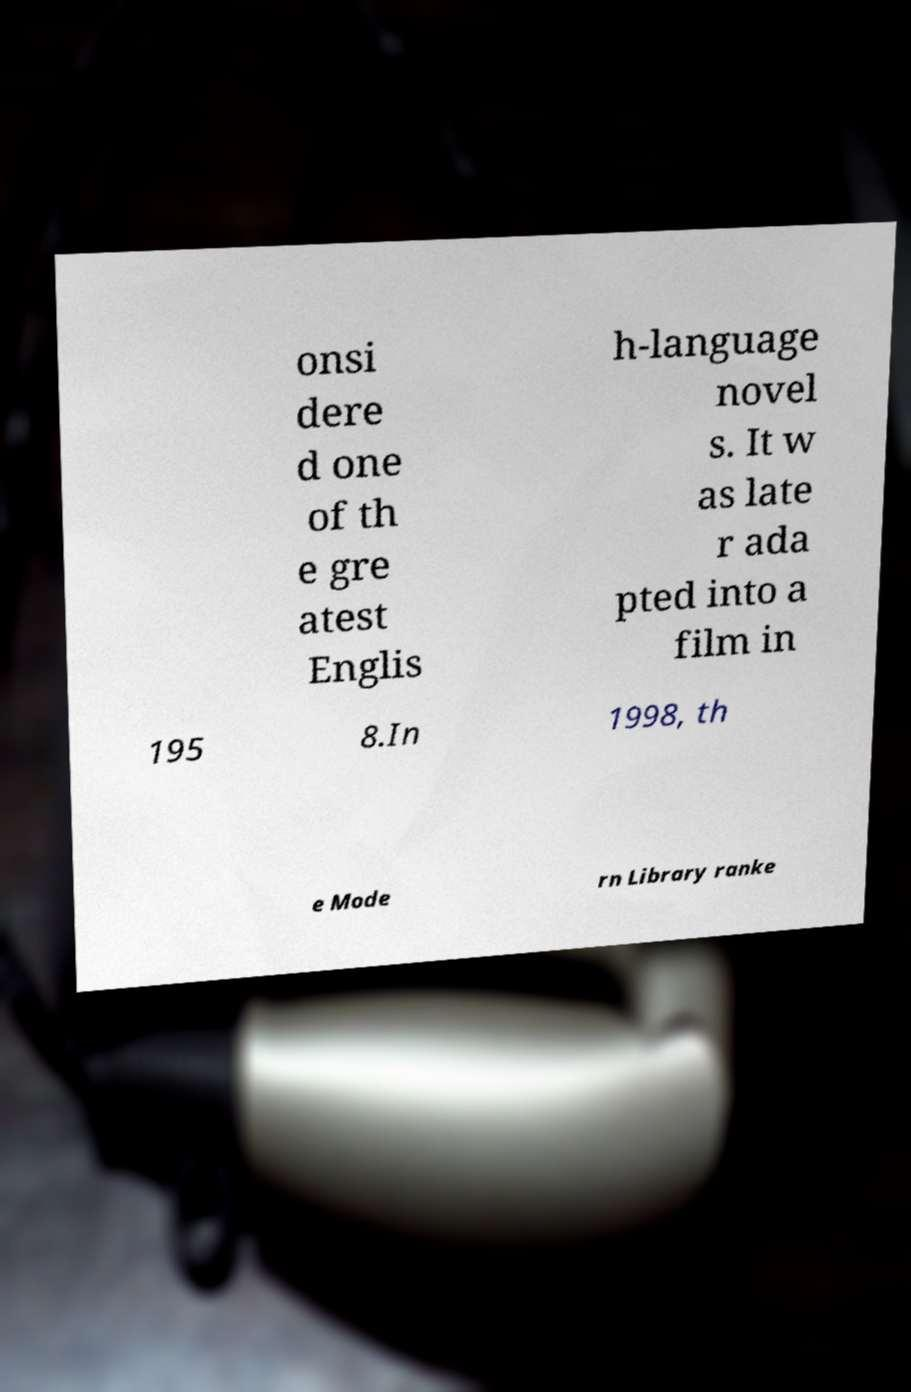There's text embedded in this image that I need extracted. Can you transcribe it verbatim? onsi dere d one of th e gre atest Englis h-language novel s. It w as late r ada pted into a film in 195 8.In 1998, th e Mode rn Library ranke 